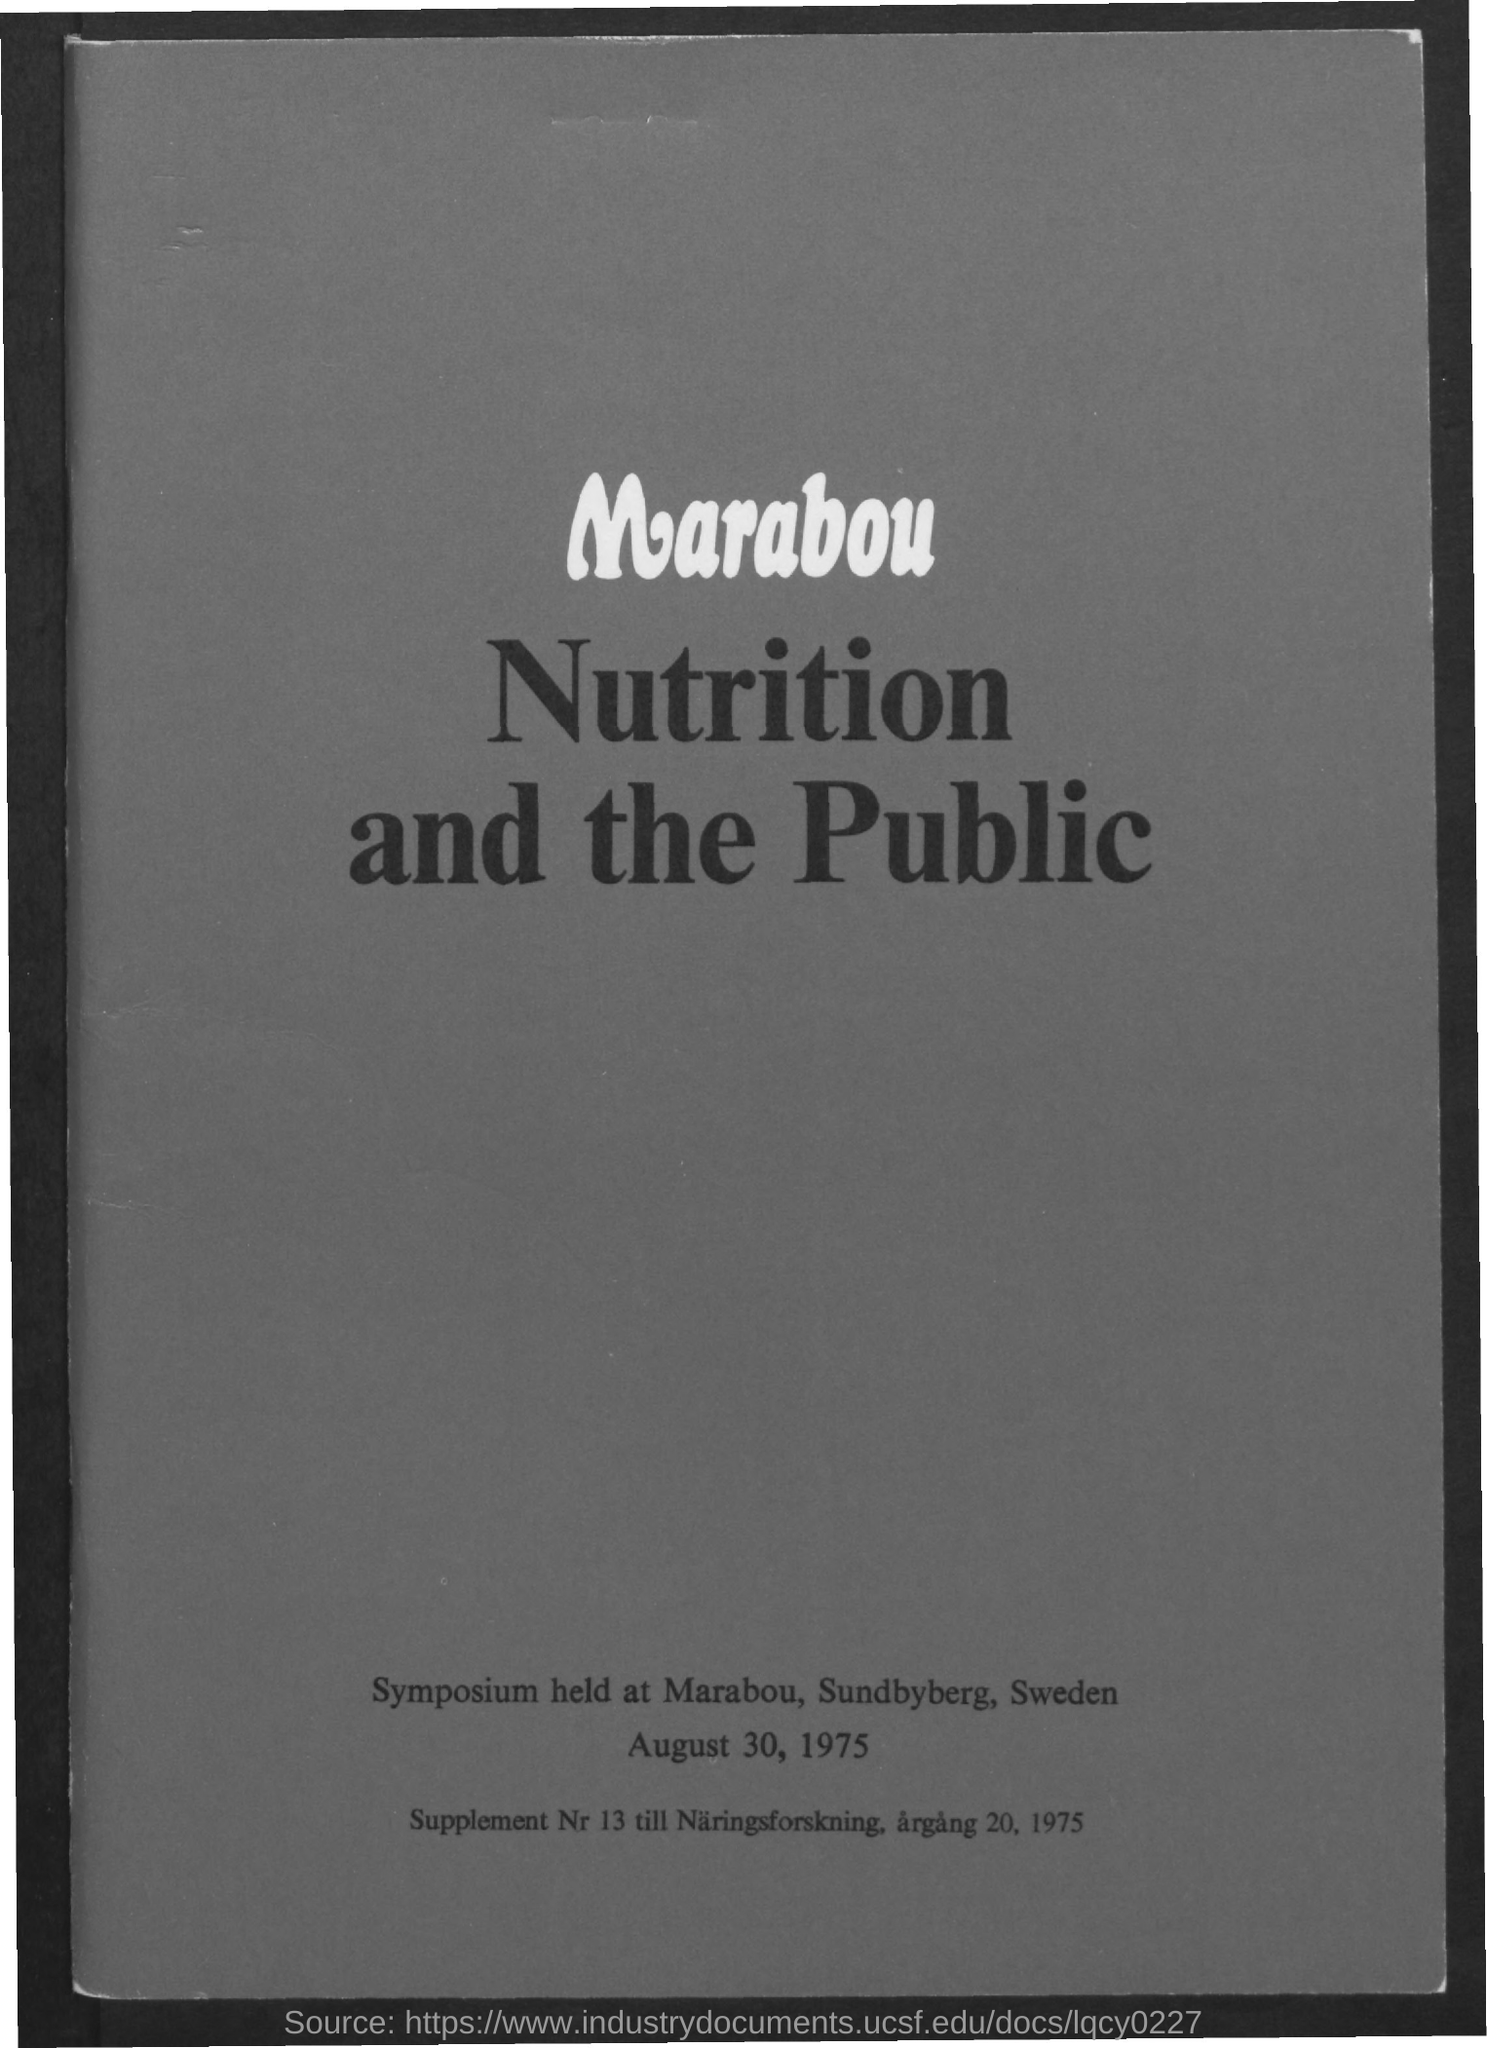What is the title of the symposium?
Make the answer very short. Nutrition and the Public. Where was the symposium held?
Ensure brevity in your answer.  Marabou, Sundbyberg, Sweden. When was the symposium held?
Offer a terse response. August 30, 1975. 